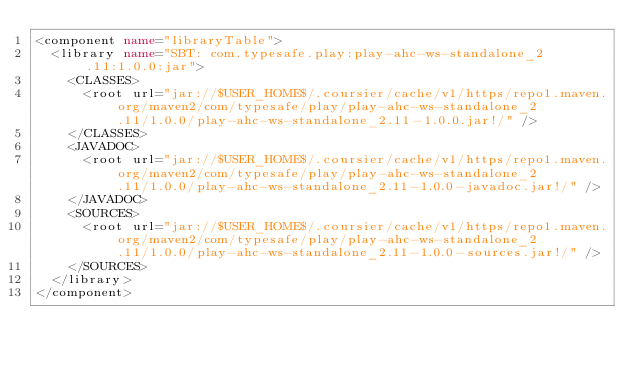Convert code to text. <code><loc_0><loc_0><loc_500><loc_500><_XML_><component name="libraryTable">
  <library name="SBT: com.typesafe.play:play-ahc-ws-standalone_2.11:1.0.0:jar">
    <CLASSES>
      <root url="jar://$USER_HOME$/.coursier/cache/v1/https/repo1.maven.org/maven2/com/typesafe/play/play-ahc-ws-standalone_2.11/1.0.0/play-ahc-ws-standalone_2.11-1.0.0.jar!/" />
    </CLASSES>
    <JAVADOC>
      <root url="jar://$USER_HOME$/.coursier/cache/v1/https/repo1.maven.org/maven2/com/typesafe/play/play-ahc-ws-standalone_2.11/1.0.0/play-ahc-ws-standalone_2.11-1.0.0-javadoc.jar!/" />
    </JAVADOC>
    <SOURCES>
      <root url="jar://$USER_HOME$/.coursier/cache/v1/https/repo1.maven.org/maven2/com/typesafe/play/play-ahc-ws-standalone_2.11/1.0.0/play-ahc-ws-standalone_2.11-1.0.0-sources.jar!/" />
    </SOURCES>
  </library>
</component></code> 